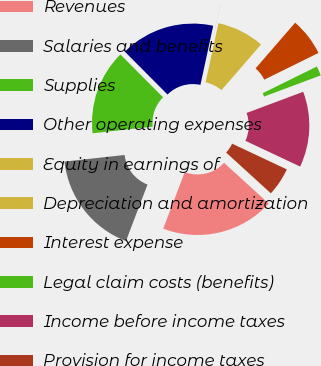<chart> <loc_0><loc_0><loc_500><loc_500><pie_chart><fcel>Revenues<fcel>Salaries and benefits<fcel>Supplies<fcel>Other operating expenses<fcel>Equity in earnings of<fcel>Depreciation and amortization<fcel>Interest expense<fcel>Legal claim costs (benefits)<fcel>Income before income taxes<fcel>Provision for income taxes<nl><fcel>19.03%<fcel>17.45%<fcel>14.28%<fcel>15.86%<fcel>0.02%<fcel>7.94%<fcel>6.35%<fcel>1.6%<fcel>12.69%<fcel>4.77%<nl></chart> 